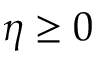<formula> <loc_0><loc_0><loc_500><loc_500>\eta \geq 0</formula> 